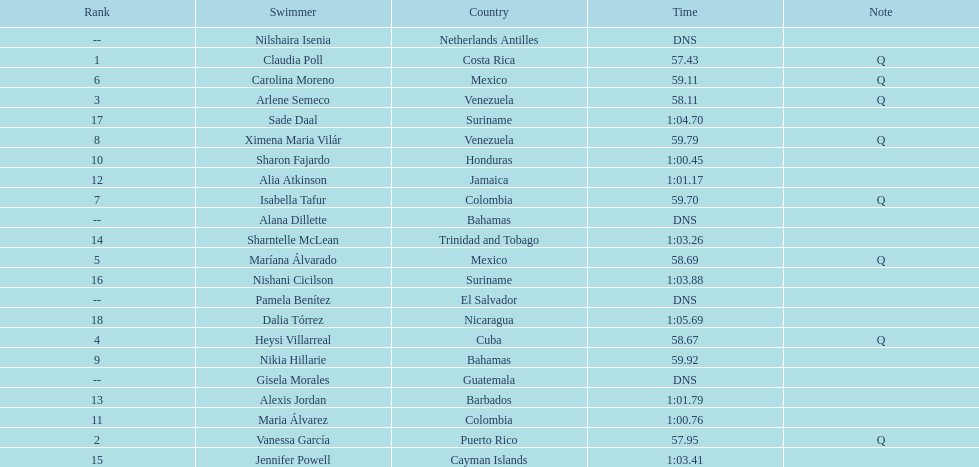How many swimmers had a time of at least 1:00 9. 